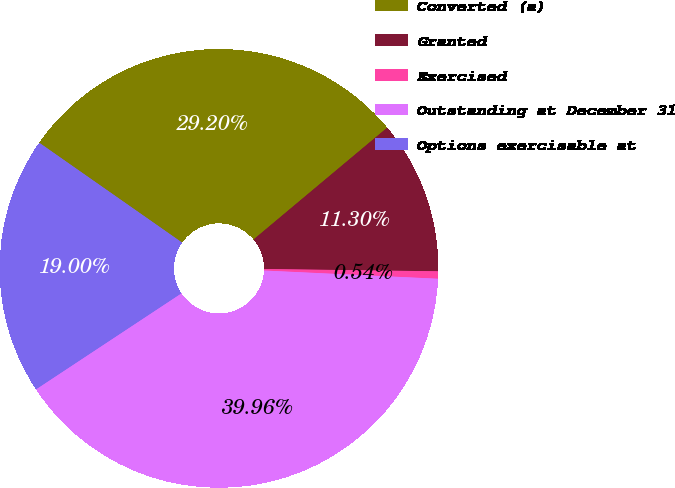Convert chart to OTSL. <chart><loc_0><loc_0><loc_500><loc_500><pie_chart><fcel>Converted (a)<fcel>Granted<fcel>Exercised<fcel>Outstanding at December 31<fcel>Options exercisable at<nl><fcel>29.2%<fcel>11.3%<fcel>0.54%<fcel>39.96%<fcel>19.0%<nl></chart> 